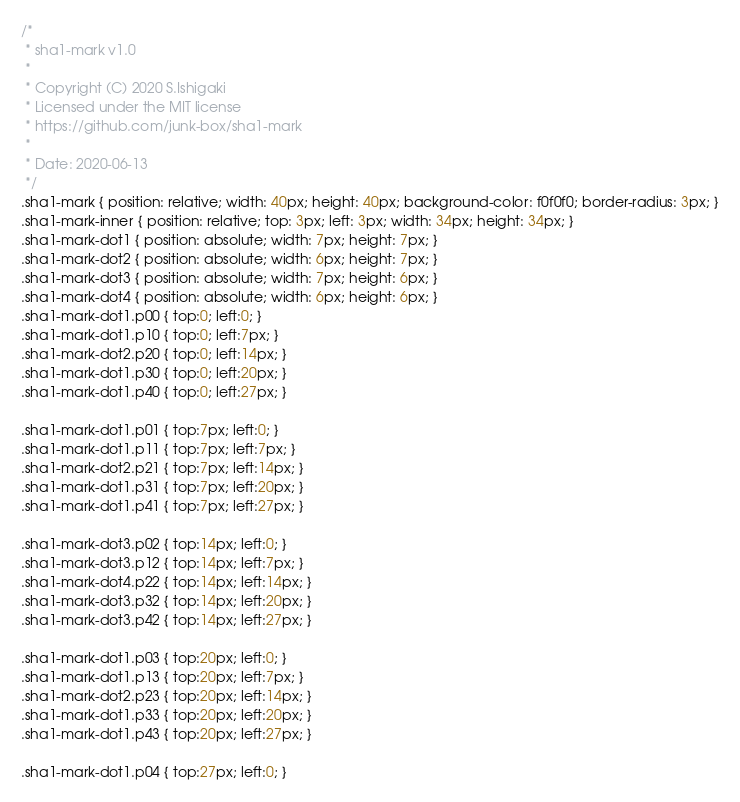Convert code to text. <code><loc_0><loc_0><loc_500><loc_500><_CSS_>/*
 * sha1-mark v1.0
 *
 * Copyright (C) 2020 S.Ishigaki
 * Licensed under the MIT license
 * https://github.com/junk-box/sha1-mark
 *
 * Date: 2020-06-13
 */
.sha1-mark { position: relative; width: 40px; height: 40px; background-color: f0f0f0; border-radius: 3px; }
.sha1-mark-inner { position: relative; top: 3px; left: 3px; width: 34px; height: 34px; }
.sha1-mark-dot1 { position: absolute; width: 7px; height: 7px; }
.sha1-mark-dot2 { position: absolute; width: 6px; height: 7px; }
.sha1-mark-dot3 { position: absolute; width: 7px; height: 6px; }
.sha1-mark-dot4 { position: absolute; width: 6px; height: 6px; }
.sha1-mark-dot1.p00 { top:0; left:0; }
.sha1-mark-dot1.p10 { top:0; left:7px; }
.sha1-mark-dot2.p20 { top:0; left:14px; }
.sha1-mark-dot1.p30 { top:0; left:20px; }
.sha1-mark-dot1.p40 { top:0; left:27px; }

.sha1-mark-dot1.p01 { top:7px; left:0; }
.sha1-mark-dot1.p11 { top:7px; left:7px; }
.sha1-mark-dot2.p21 { top:7px; left:14px; }
.sha1-mark-dot1.p31 { top:7px; left:20px; }
.sha1-mark-dot1.p41 { top:7px; left:27px; }

.sha1-mark-dot3.p02 { top:14px; left:0; }
.sha1-mark-dot3.p12 { top:14px; left:7px; }
.sha1-mark-dot4.p22 { top:14px; left:14px; }
.sha1-mark-dot3.p32 { top:14px; left:20px; }
.sha1-mark-dot3.p42 { top:14px; left:27px; }

.sha1-mark-dot1.p03 { top:20px; left:0; }
.sha1-mark-dot1.p13 { top:20px; left:7px; }
.sha1-mark-dot2.p23 { top:20px; left:14px; }
.sha1-mark-dot1.p33 { top:20px; left:20px; }
.sha1-mark-dot1.p43 { top:20px; left:27px; }

.sha1-mark-dot1.p04 { top:27px; left:0; }</code> 